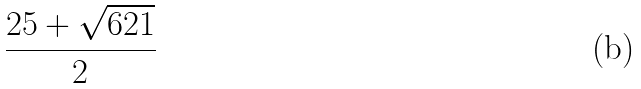Convert formula to latex. <formula><loc_0><loc_0><loc_500><loc_500>\frac { 2 5 + \sqrt { 6 2 1 } } { 2 }</formula> 